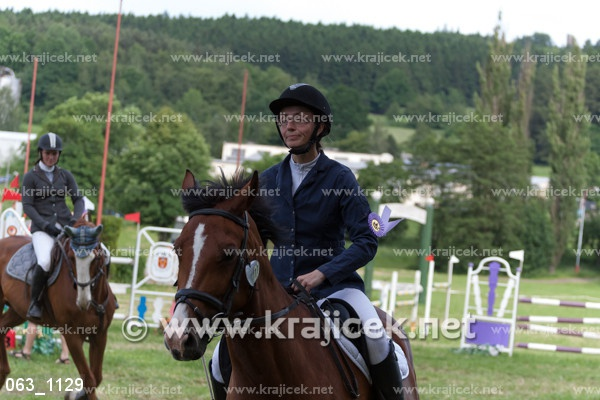Describe the objects in this image and their specific colors. I can see horse in white, black, gray, maroon, and darkgray tones, people in white, black, gray, navy, and darkgray tones, horse in white, black, maroon, gray, and darkgray tones, and people in white, black, gray, and lavender tones in this image. 